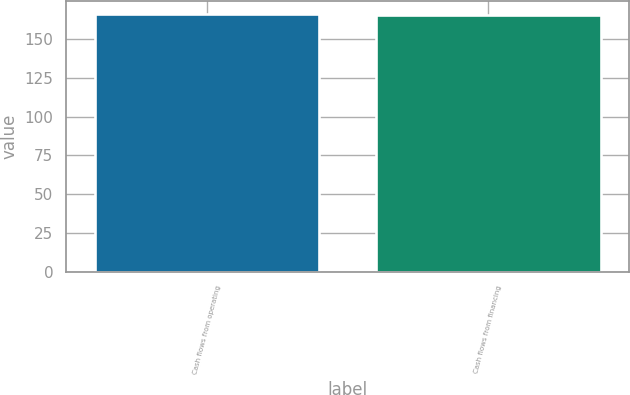Convert chart. <chart><loc_0><loc_0><loc_500><loc_500><bar_chart><fcel>Cash flows from operating<fcel>Cash flows from financing<nl><fcel>166.4<fcel>165.5<nl></chart> 